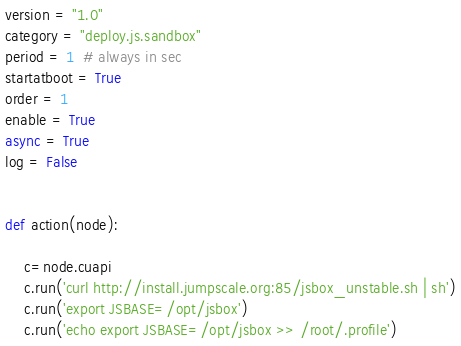<code> <loc_0><loc_0><loc_500><loc_500><_Python_>version = "1.0"
category = "deploy.js.sandbox"
period = 1  # always in sec
startatboot = True
order = 1
enable = True
async = True
log = False


def action(node):

    c=node.cuapi
    c.run('curl http://install.jumpscale.org:85/jsbox_unstable.sh | sh')
    c.run('export JSBASE=/opt/jsbox')
    c.run('echo export JSBASE=/opt/jsbox >> /root/.profile')
</code> 